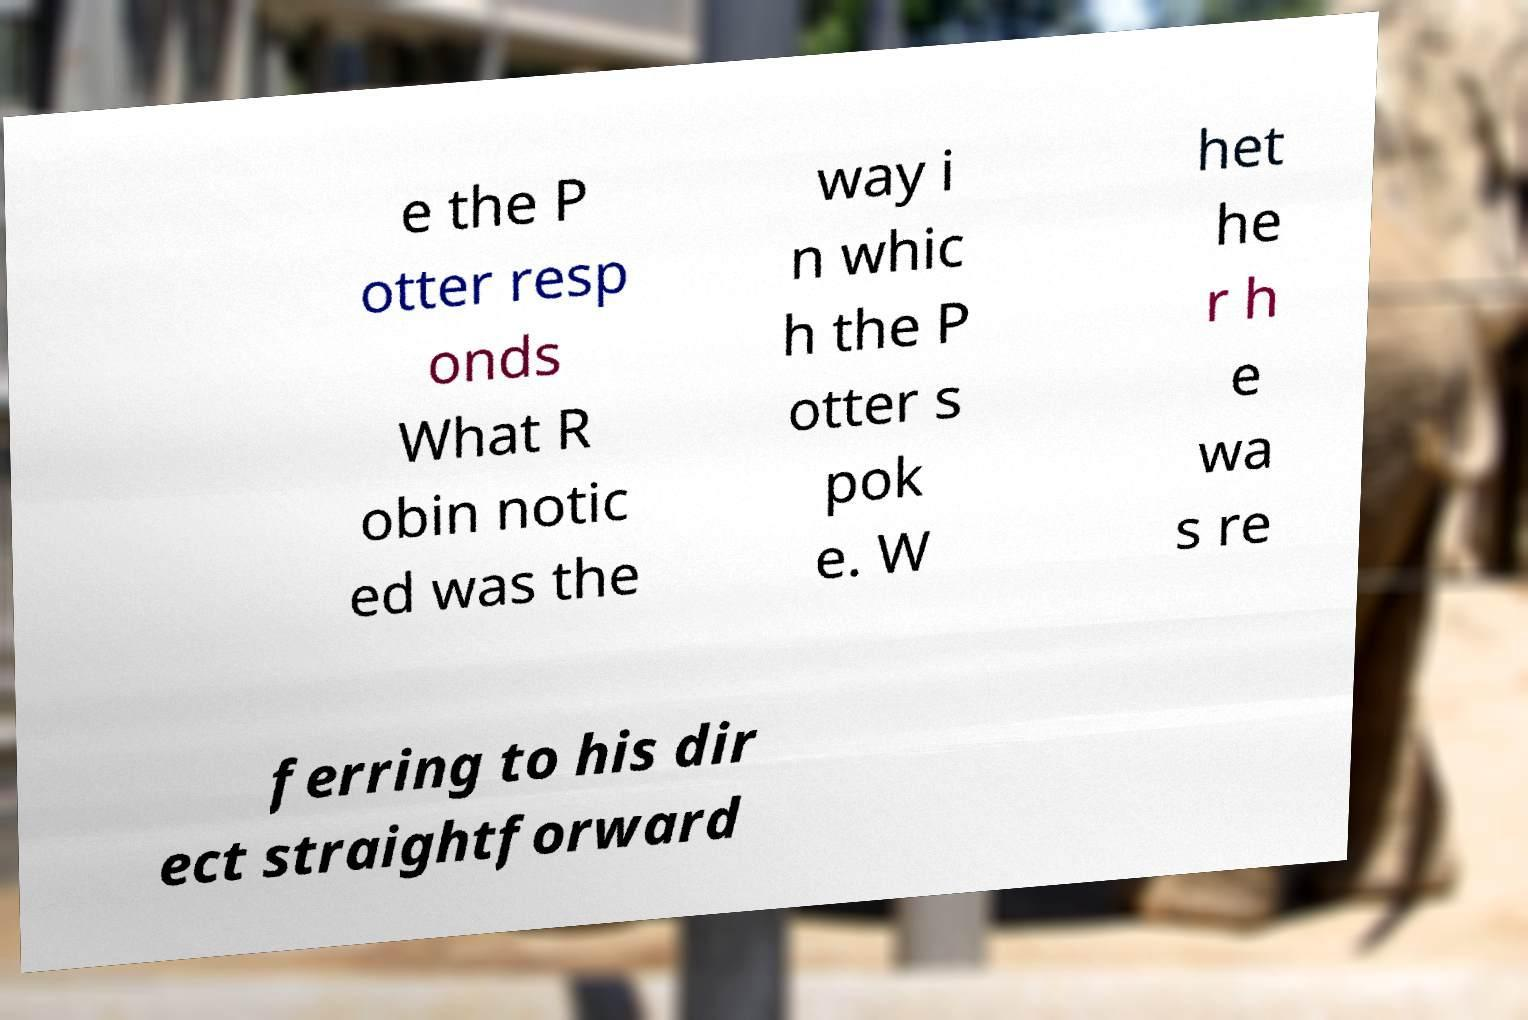Could you extract and type out the text from this image? e the P otter resp onds What R obin notic ed was the way i n whic h the P otter s pok e. W het he r h e wa s re ferring to his dir ect straightforward 